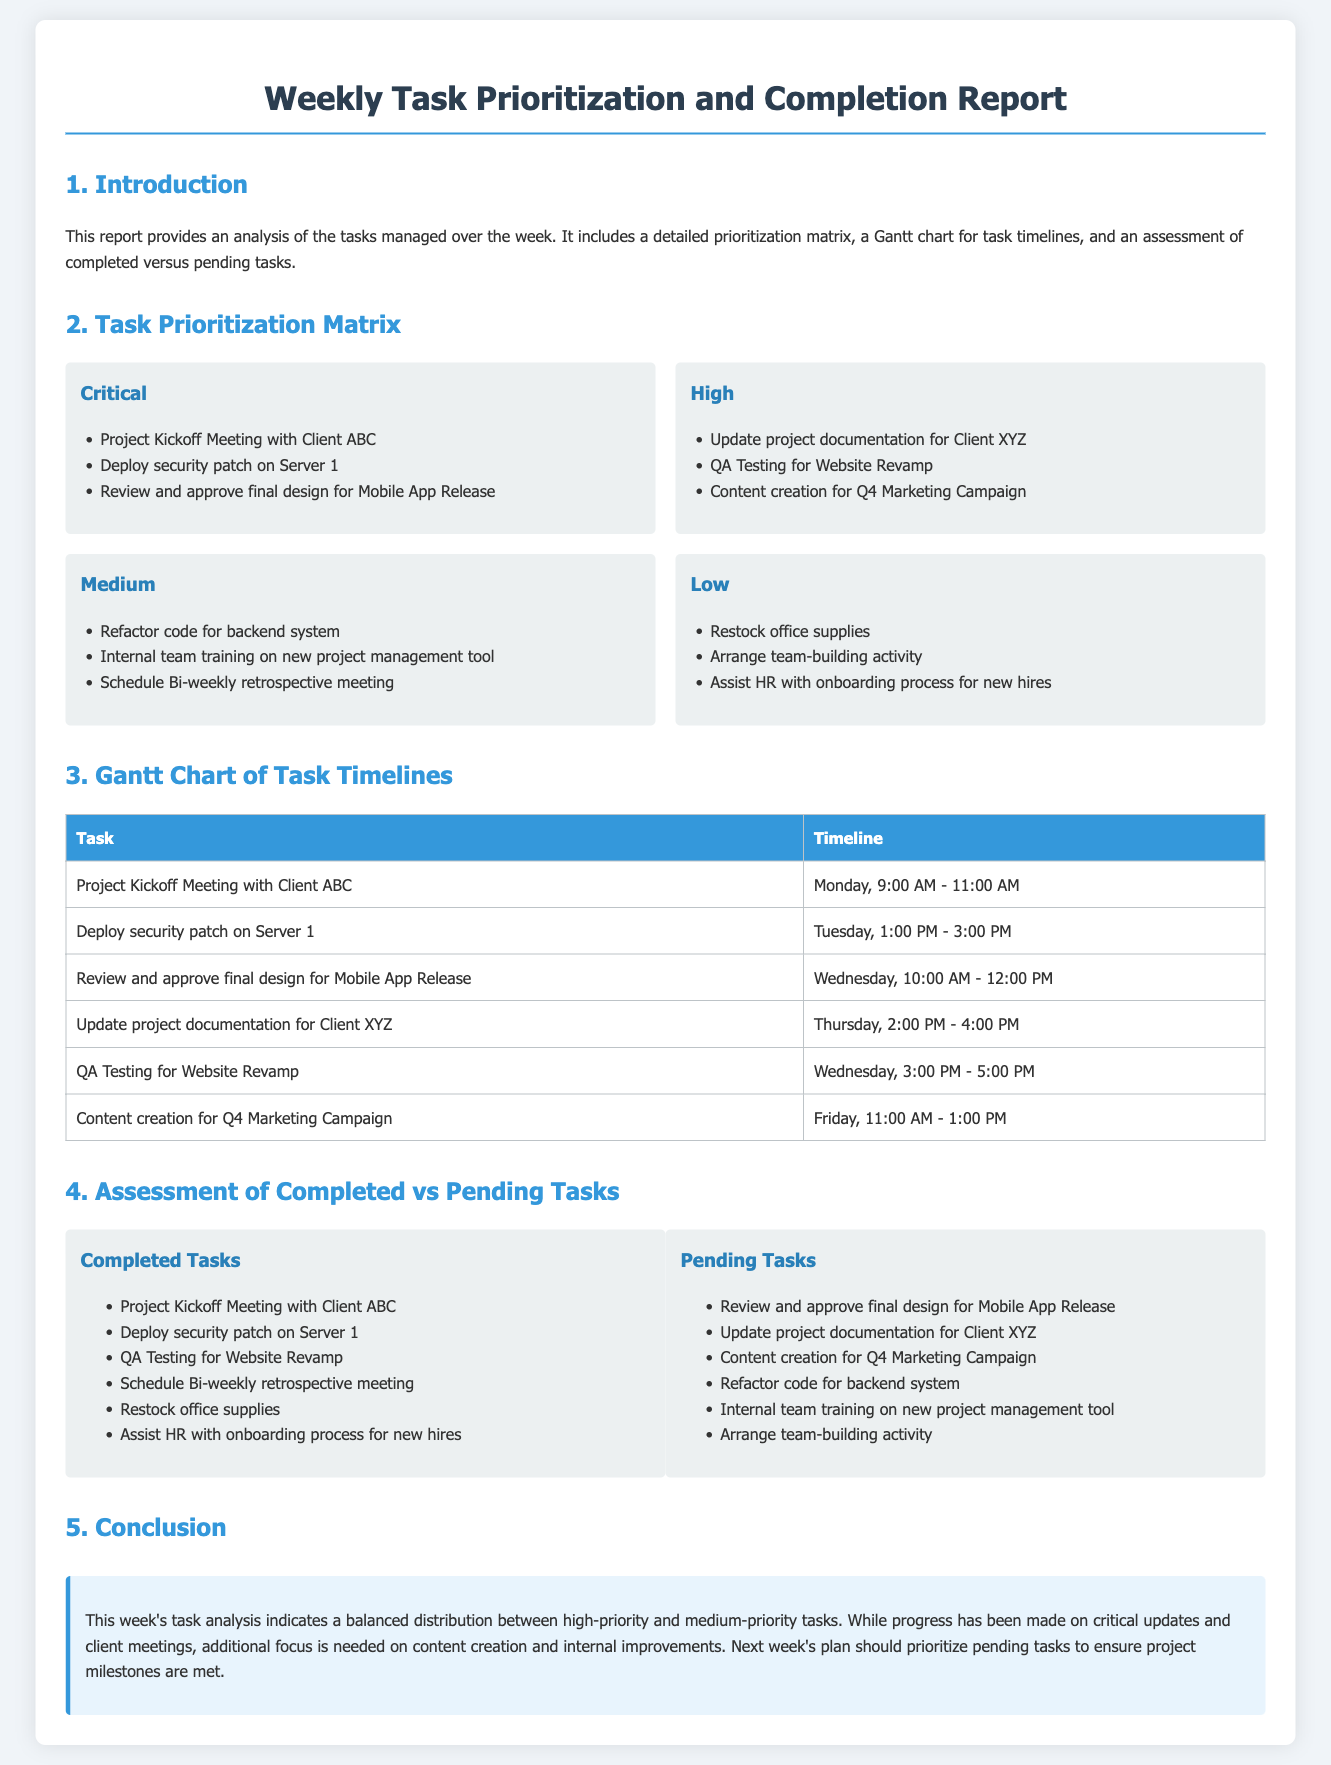What is the title of the report? The title of the report can be found at the top of the document, emphasizing its focus.
Answer: Weekly Task Prioritization and Completion Report How many tasks are categorized as Critical? The count of tasks in the Critical category is specified in the prioritization matrix section of the document.
Answer: 3 What task is scheduled for Wednesday at 10:00 AM? The Gantt chart provides the timeline for tasks, indicating specific scheduled times.
Answer: Review and approve final design for Mobile App Release Which task was completed relating to Client ABC? The completed tasks list details specific tasks associated with Client ABC.
Answer: Project Kickoff Meeting with Client ABC How many pending tasks are listed? The pending tasks section enumerates the tasks that are yet to be completed.
Answer: 6 What is the conclusion about next week’s focus? The conclusion summarizes the document and suggests a direction for the upcoming week based on the week's analysis.
Answer: Focus is needed on content creation and internal improvements Which task was performed on Tuesday? The Gantt chart specifies the timeline for tasks, including the day of the week associated with each task.
Answer: Deploy security patch on Server 1 What is the priority level of the task ‘Refactor code for backend system’? The task prioritization matrix categorizes tasks by their priority level.
Answer: Medium 